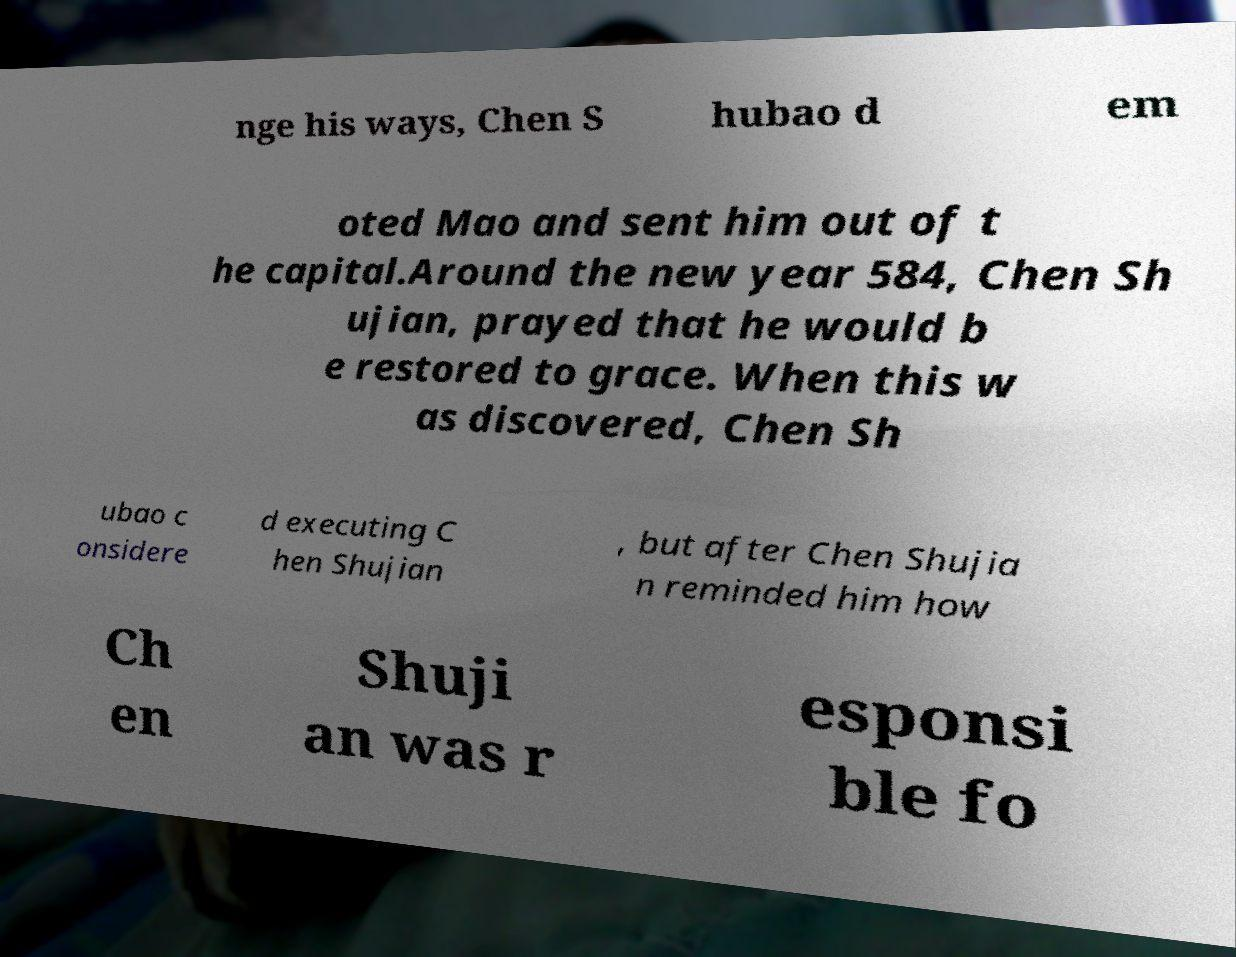Could you extract and type out the text from this image? nge his ways, Chen S hubao d em oted Mao and sent him out of t he capital.Around the new year 584, Chen Sh ujian, prayed that he would b e restored to grace. When this w as discovered, Chen Sh ubao c onsidere d executing C hen Shujian , but after Chen Shujia n reminded him how Ch en Shuji an was r esponsi ble fo 